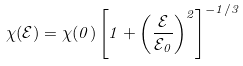Convert formula to latex. <formula><loc_0><loc_0><loc_500><loc_500>\chi ( { \mathcal { E } } ) = \chi ( 0 ) \left [ 1 + \left ( \frac { \mathcal { E } } { \mathcal { E } _ { 0 } } \right ) ^ { 2 } \right ] ^ { - 1 / 3 }</formula> 